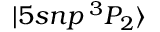Convert formula to latex. <formula><loc_0><loc_0><loc_500><loc_500>| 5 s n p \, ^ { 3 } P _ { 2 } \rangle</formula> 